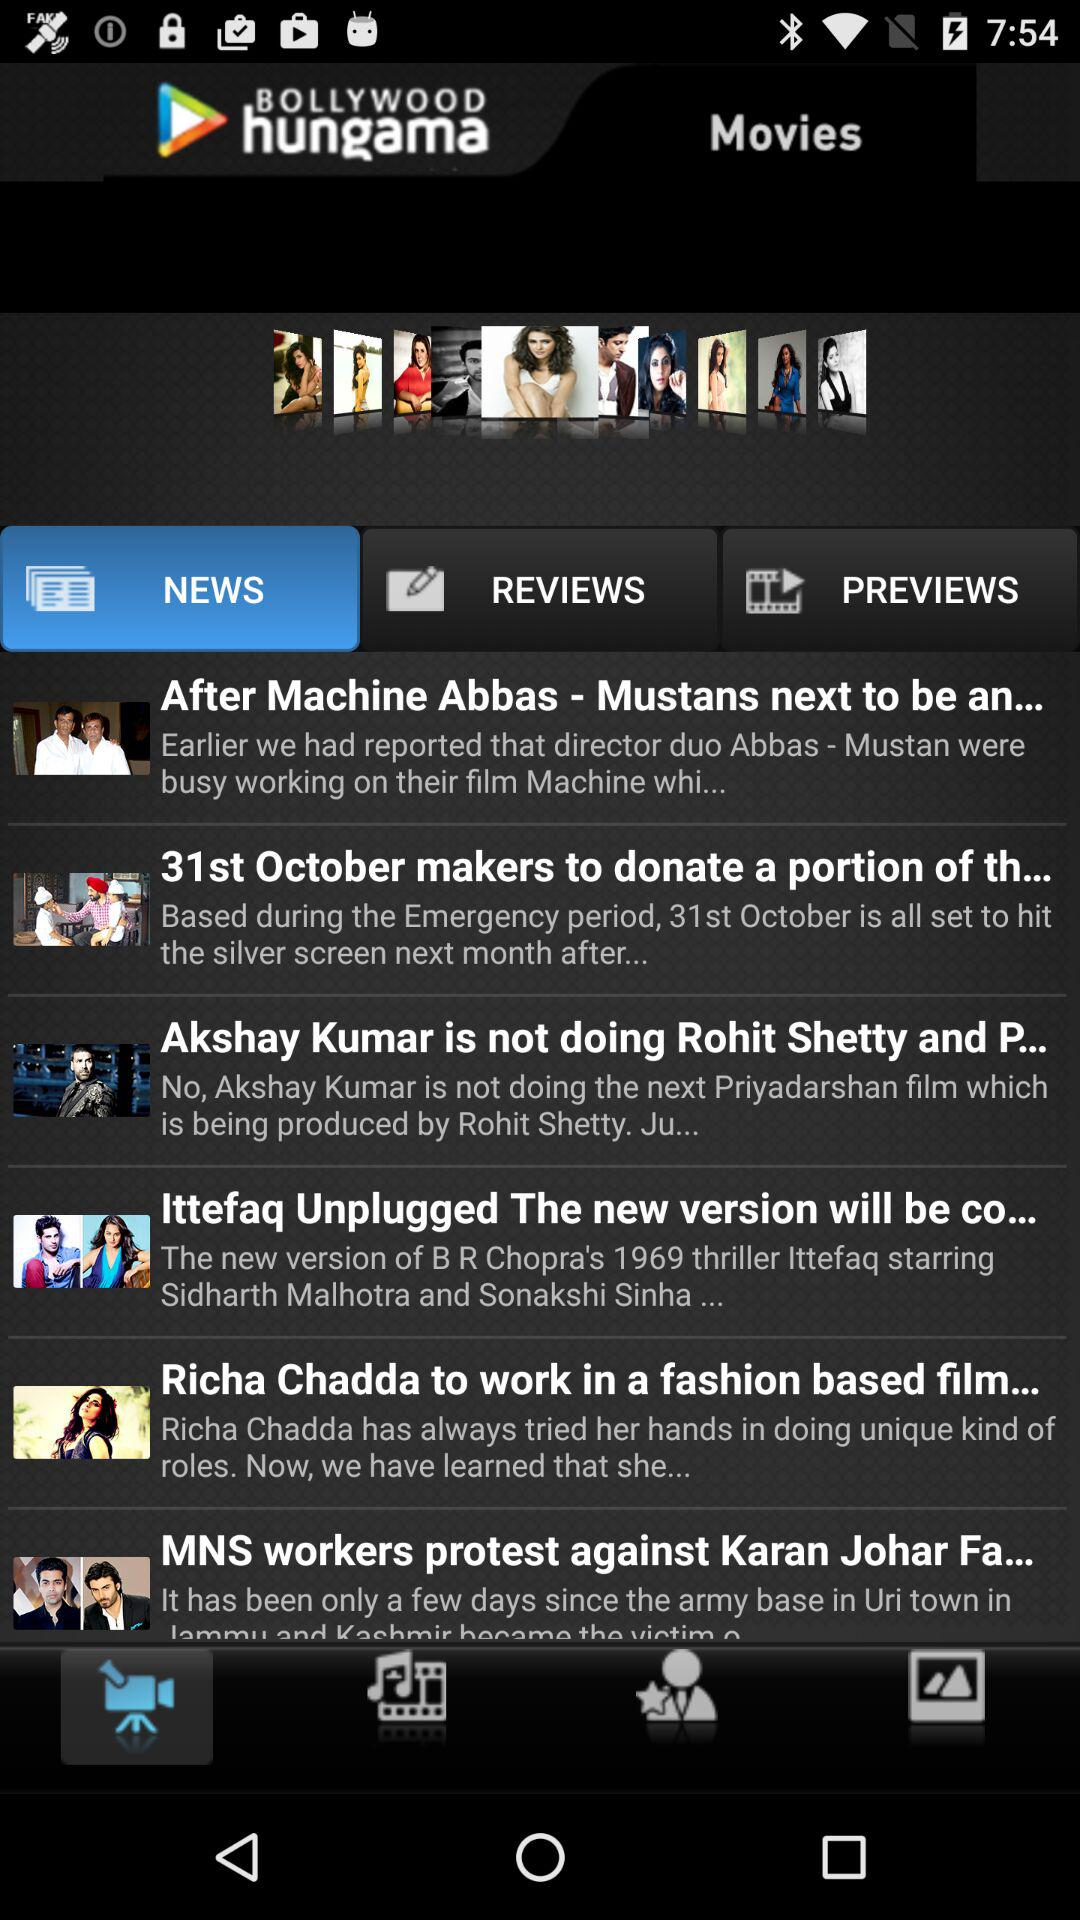Which tab is selected? The selected tabs are "NEWS" and "Video Recorder". 